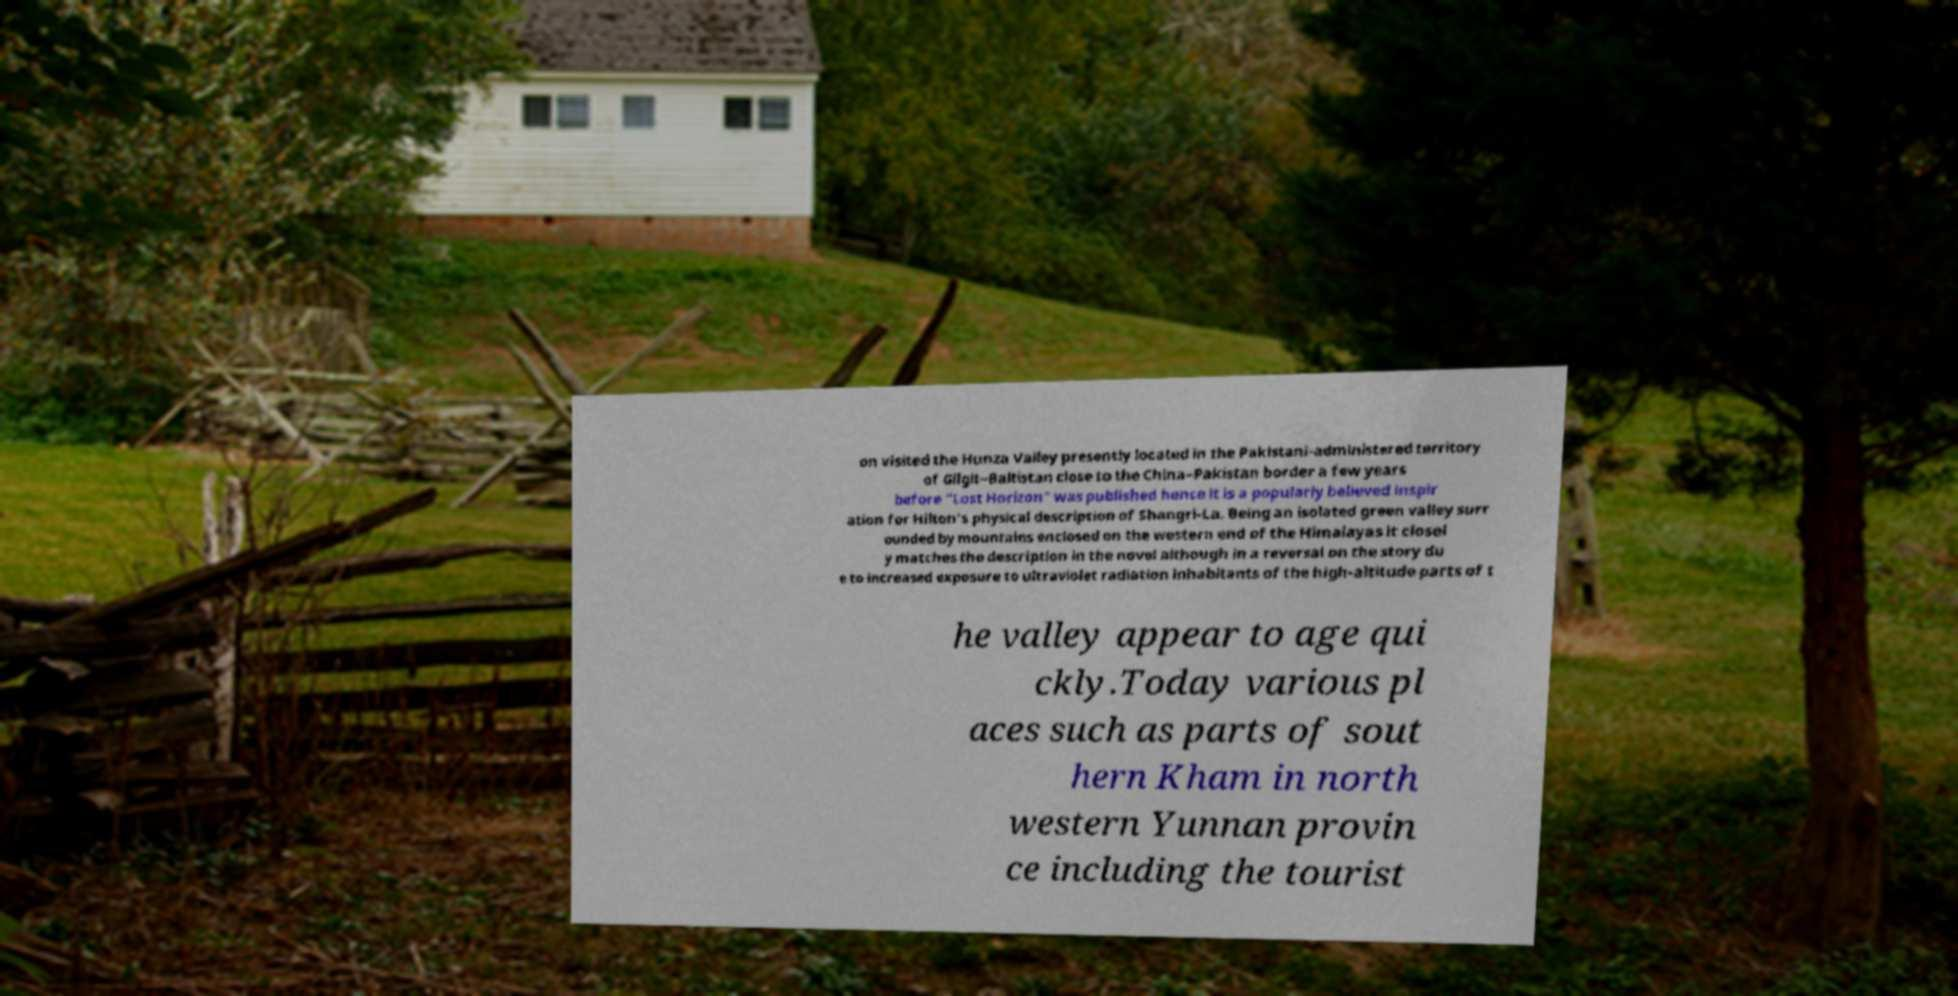Can you read and provide the text displayed in the image?This photo seems to have some interesting text. Can you extract and type it out for me? on visited the Hunza Valley presently located in the Pakistani-administered territory of Gilgit−Baltistan close to the China–Pakistan border a few years before "Lost Horizon" was published hence it is a popularly believed inspir ation for Hilton's physical description of Shangri-La. Being an isolated green valley surr ounded by mountains enclosed on the western end of the Himalayas it closel y matches the description in the novel although in a reversal on the story du e to increased exposure to ultraviolet radiation inhabitants of the high-altitude parts of t he valley appear to age qui ckly.Today various pl aces such as parts of sout hern Kham in north western Yunnan provin ce including the tourist 